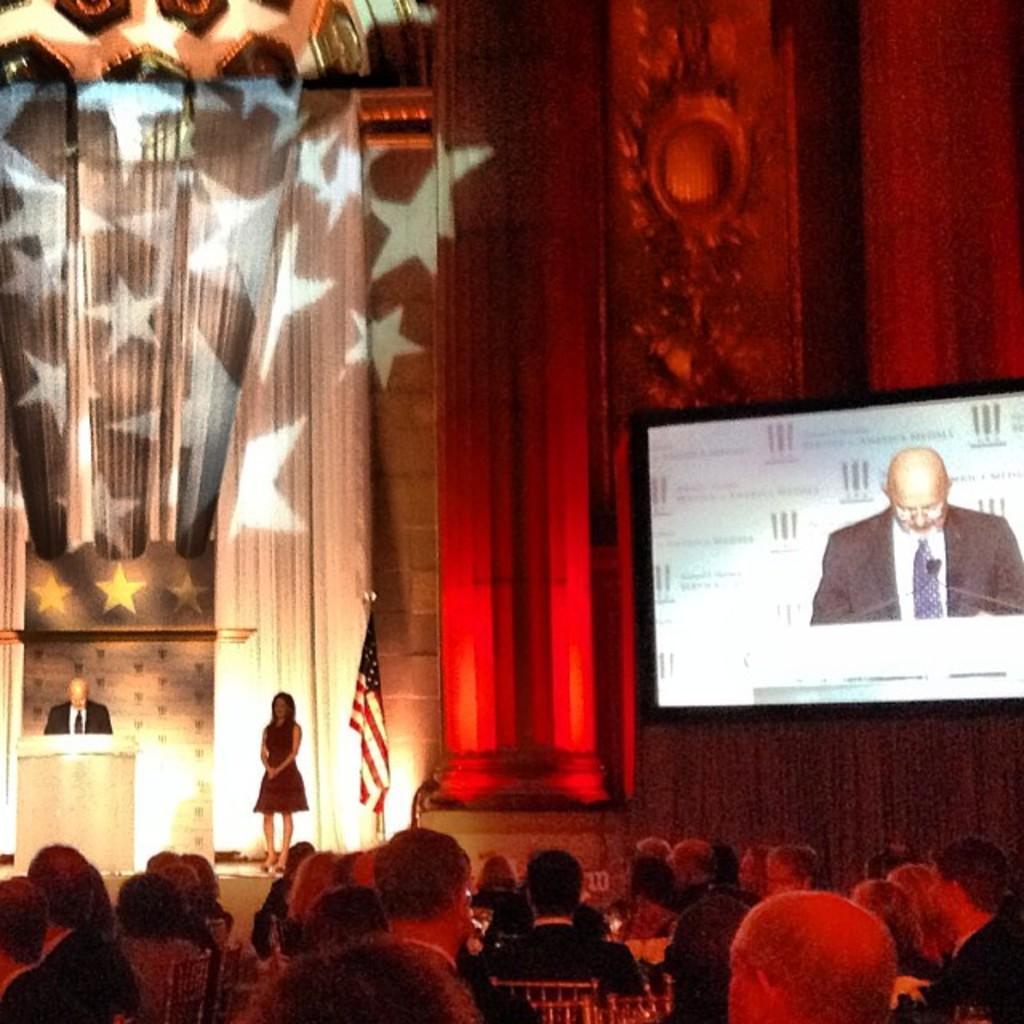Could you give a brief overview of what you see in this image? In this image I can see the group of people. In-front of these people I can see two people, flag and the screen. I can see one person standing in-front of the podium. In the background I can see the wall. 